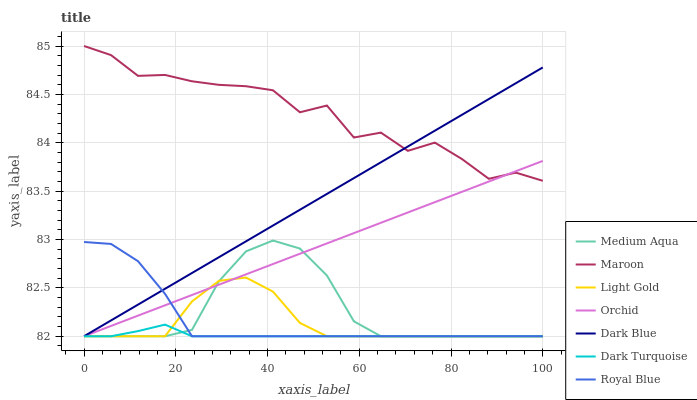Does Maroon have the minimum area under the curve?
Answer yes or no. No. Does Dark Turquoise have the maximum area under the curve?
Answer yes or no. No. Is Dark Turquoise the smoothest?
Answer yes or no. No. Is Dark Turquoise the roughest?
Answer yes or no. No. Does Maroon have the lowest value?
Answer yes or no. No. Does Dark Turquoise have the highest value?
Answer yes or no. No. Is Royal Blue less than Maroon?
Answer yes or no. Yes. Is Maroon greater than Dark Turquoise?
Answer yes or no. Yes. Does Royal Blue intersect Maroon?
Answer yes or no. No. 